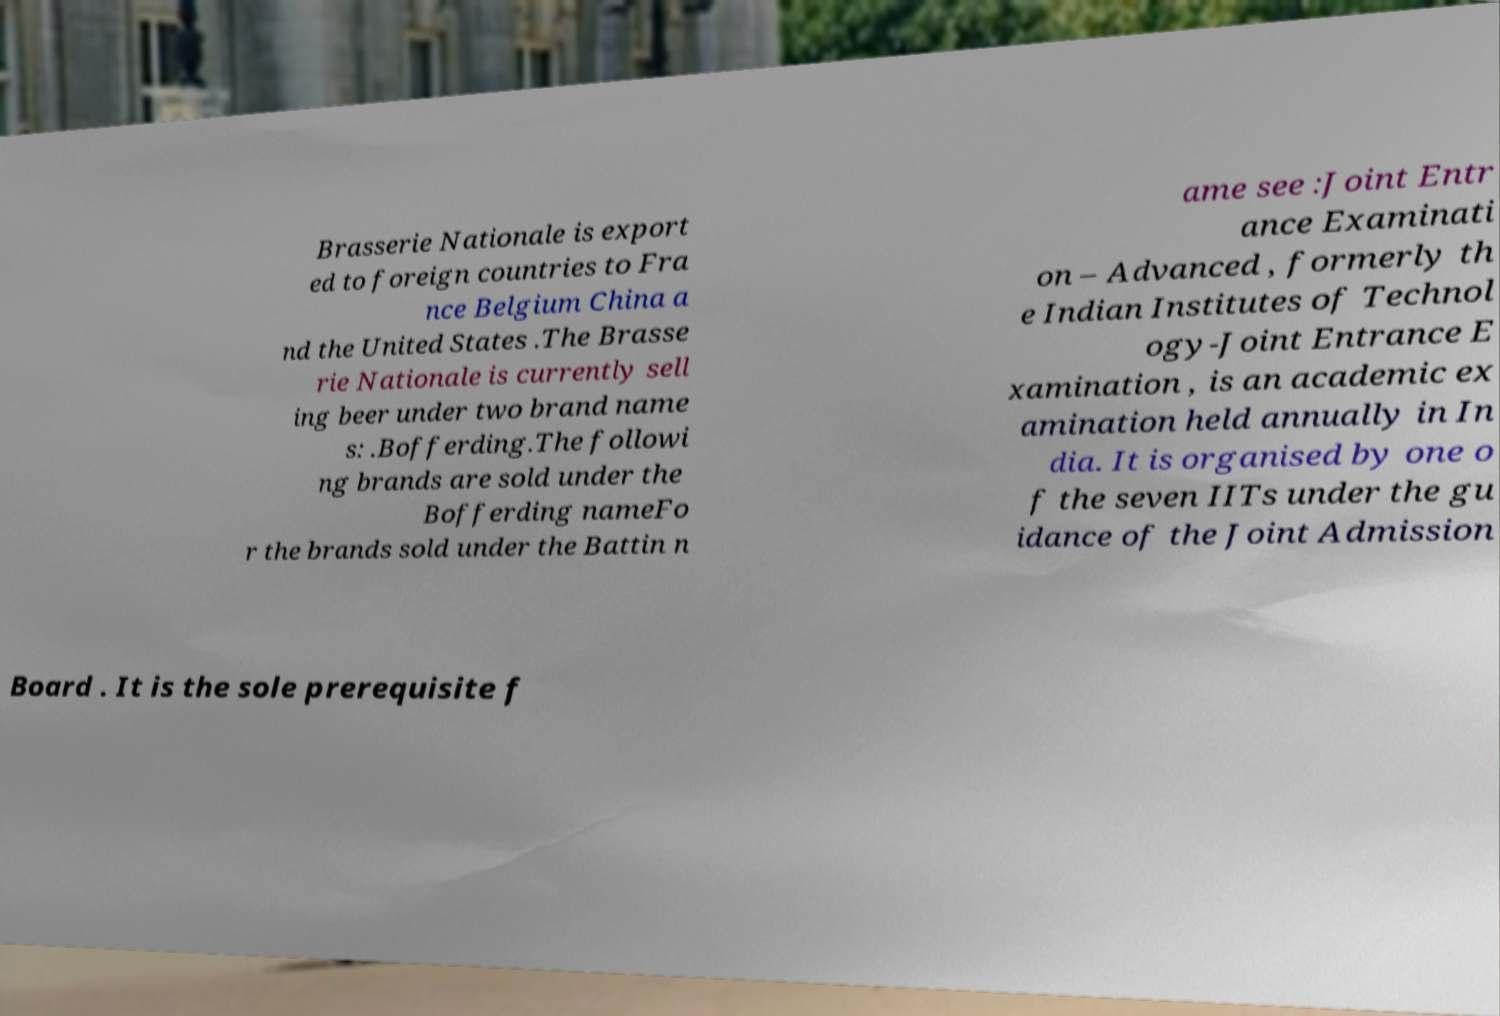There's text embedded in this image that I need extracted. Can you transcribe it verbatim? Brasserie Nationale is export ed to foreign countries to Fra nce Belgium China a nd the United States .The Brasse rie Nationale is currently sell ing beer under two brand name s: .Bofferding.The followi ng brands are sold under the Bofferding nameFo r the brands sold under the Battin n ame see :Joint Entr ance Examinati on – Advanced , formerly th e Indian Institutes of Technol ogy-Joint Entrance E xamination , is an academic ex amination held annually in In dia. It is organised by one o f the seven IITs under the gu idance of the Joint Admission Board . It is the sole prerequisite f 